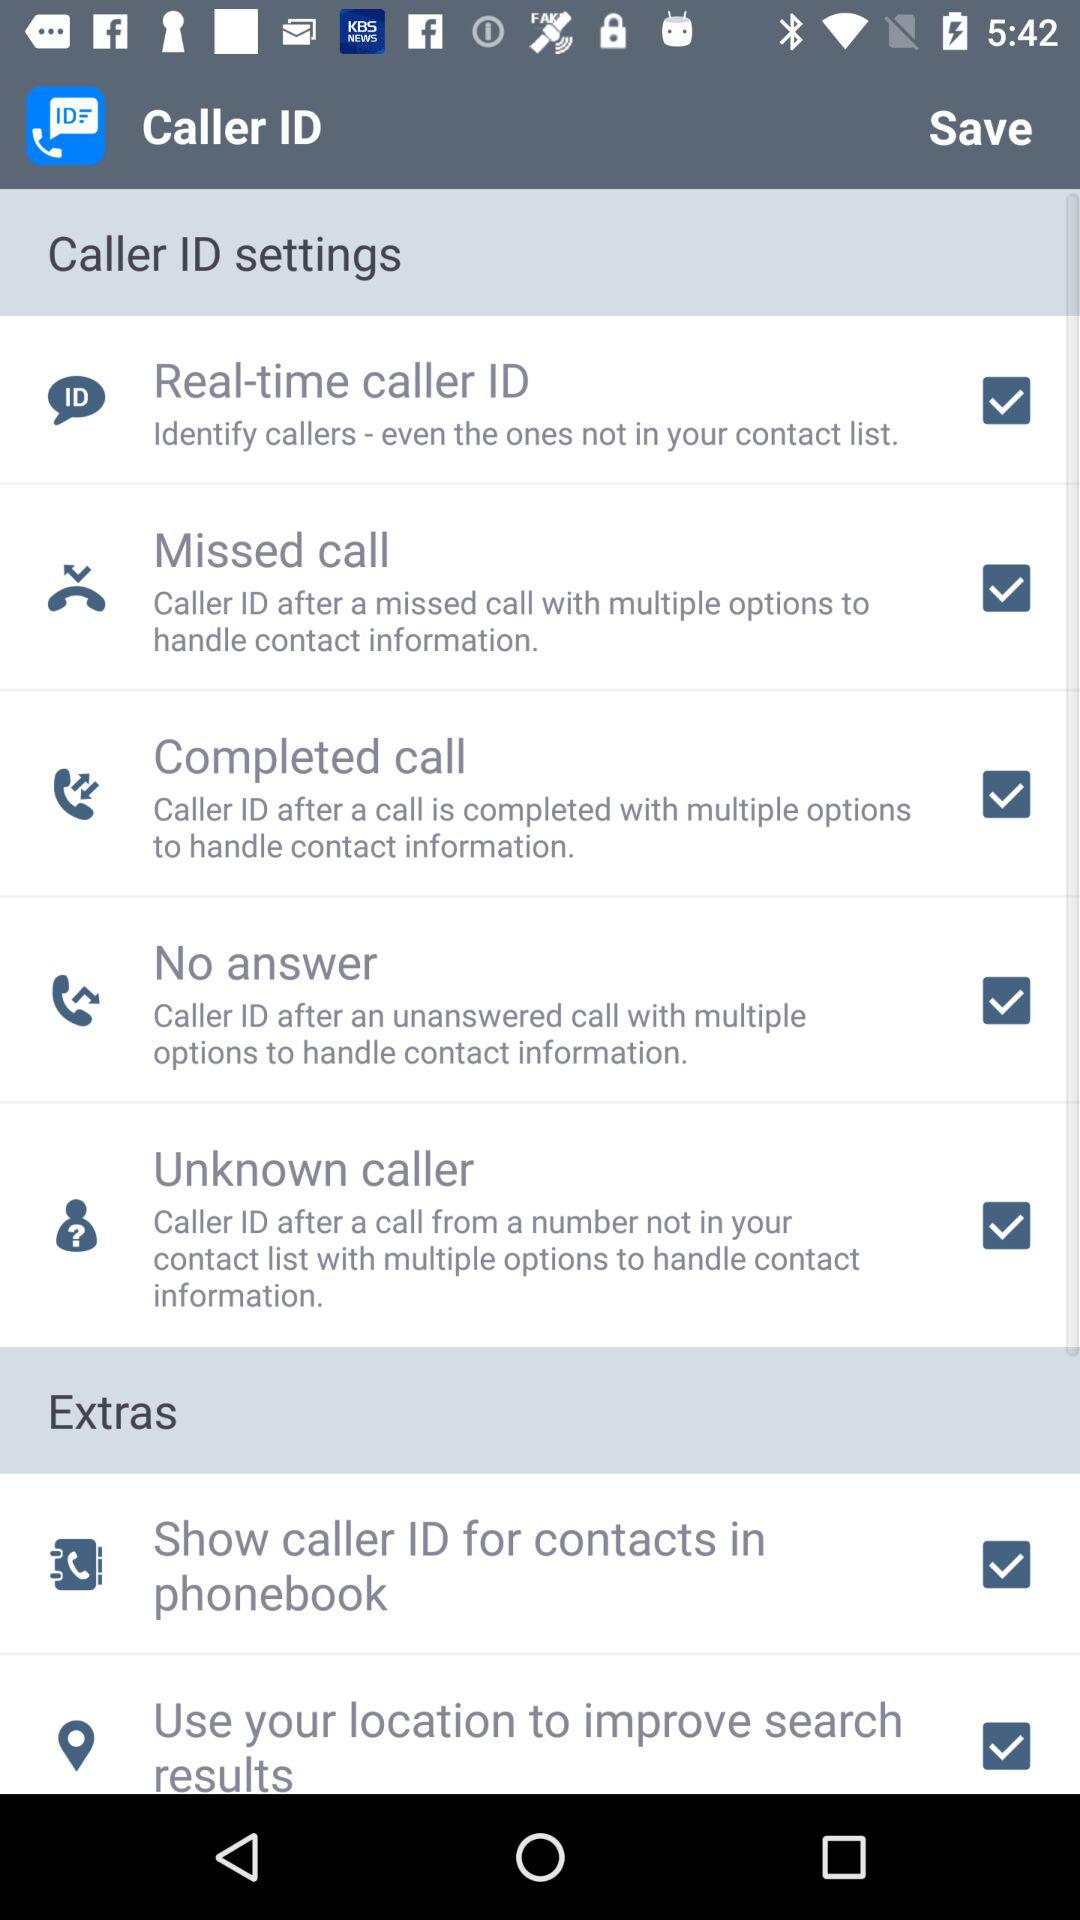Is "Unknown caller" checked or not?
Answer the question using a single word or phrase. It is "checked". 